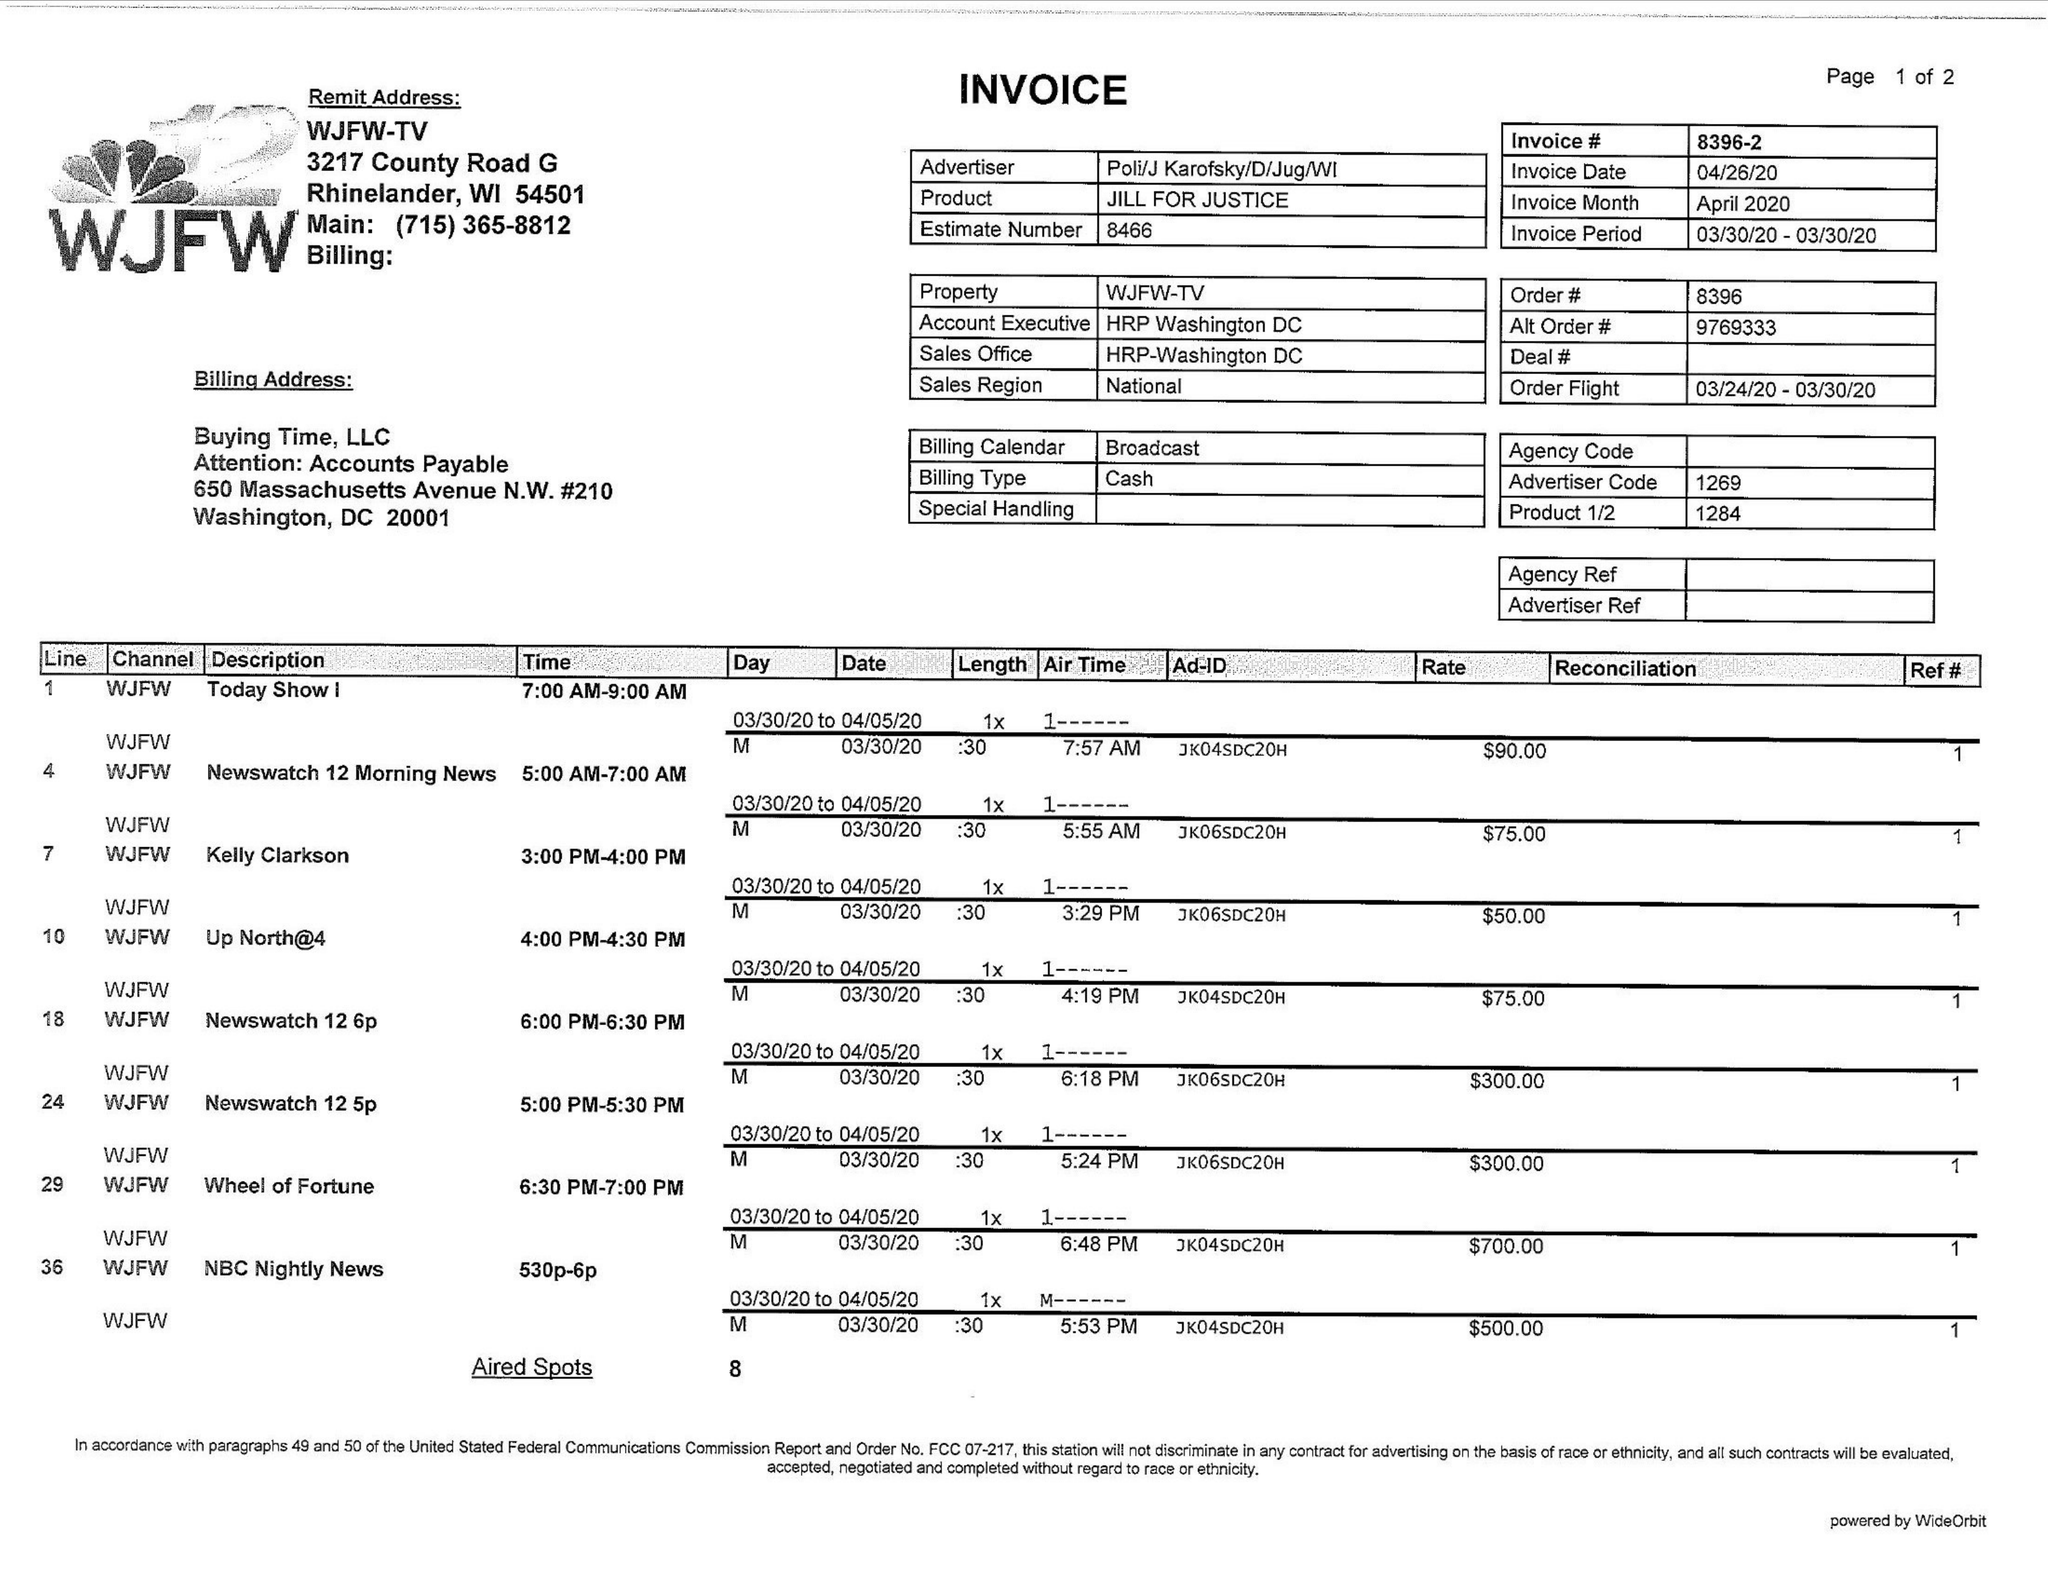What is the value for the advertiser?
Answer the question using a single word or phrase. POLI/JKAROFSKY/D/JUG/WI 